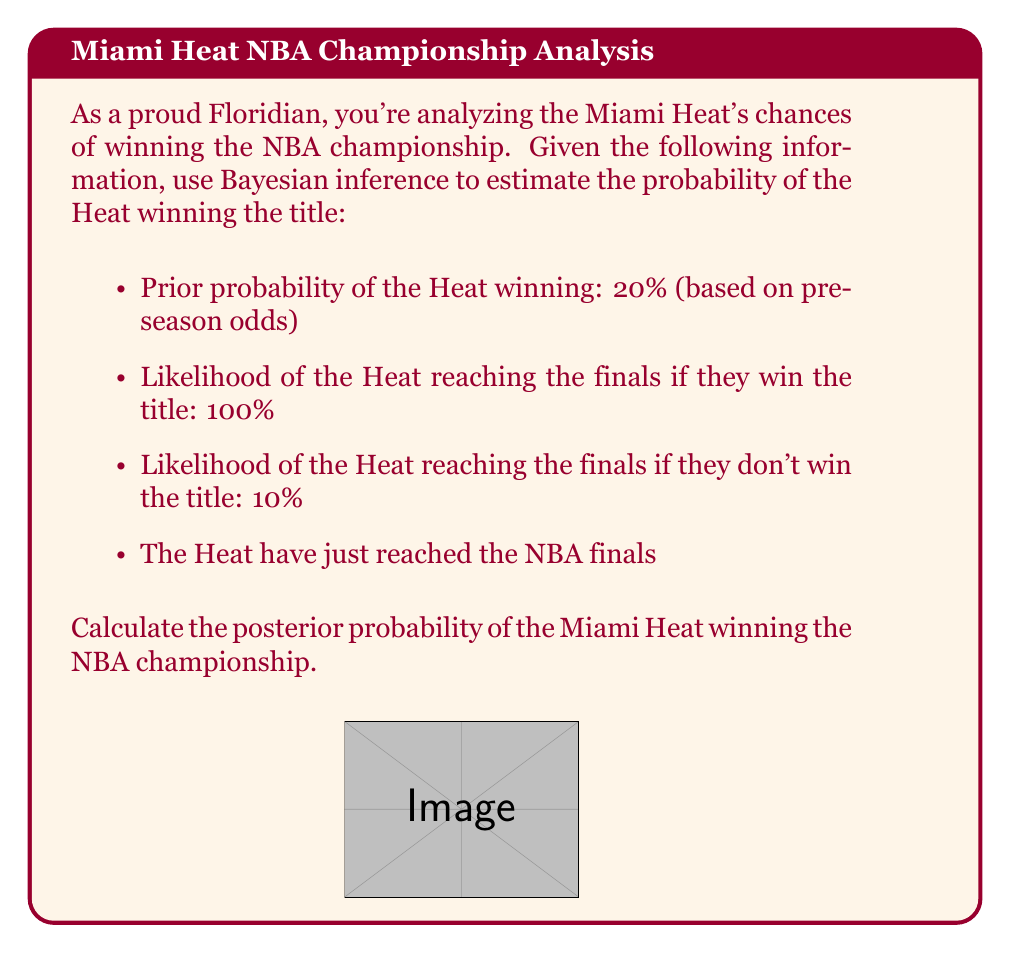Can you answer this question? Let's approach this step-by-step using Bayes' theorem:

1) Define our events:
   W: Heat wins the championship
   F: Heat reaches the finals

2) Given information:
   P(W) = 0.20 (prior probability)
   P(F|W) = 1.00 (likelihood if they win)
   P(F|not W) = 0.10 (likelihood if they don't win)
   We know F has occurred (Heat reached the finals)

3) Bayes' theorem:

   $$P(W|F) = \frac{P(F|W) \cdot P(W)}{P(F)}$$

4) Calculate P(F) using the law of total probability:
   
   $$P(F) = P(F|W) \cdot P(W) + P(F|not W) \cdot P(not W)$$
   $$P(F) = 1.00 \cdot 0.20 + 0.10 \cdot 0.80 = 0.20 + 0.08 = 0.28$$

5) Now we can apply Bayes' theorem:

   $$P(W|F) = \frac{1.00 \cdot 0.20}{0.28} = \frac{0.20}{0.28} = 0.7142857...$$

6) Convert to a percentage: 0.7142857... * 100% ≈ 71.43%

Thus, given that the Heat have reached the finals, the posterior probability of them winning the championship is approximately 71.43%.
Answer: 71.43% 